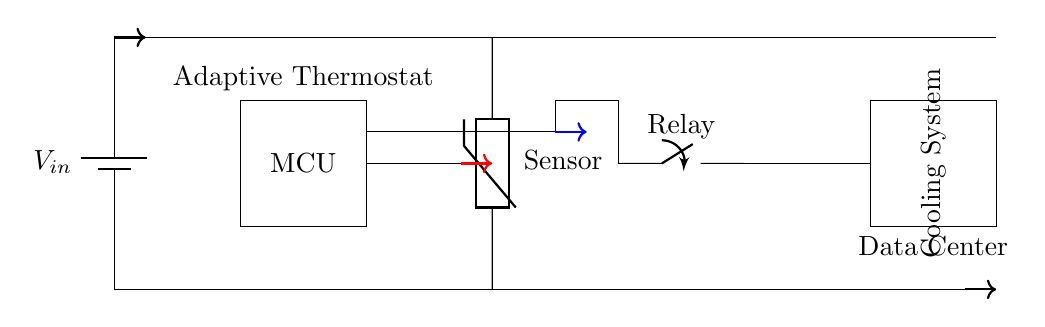What component is used to sense temperature in this circuit? The component used to sense temperature is labeled as "Sensor" in the circuit, which represents a thermistor.
Answer: Thermistor What is the role of the relay in this circuit? The relay in the circuit is labeled as "Relay" and is used to control the power to the cooling system, allowing it to turn on or off based on the commands from the microcontroller.
Answer: Control power What does "MCU" stand for? "MCU" stands for Microcontroller Unit, which is responsible for processing the temperature data and deciding when to activate the relay for the cooling system.
Answer: Microcontroller Unit What is the purpose of the cooling system in the data center? The cooling system's purpose is to maintain optimal temperature conditions within the data center to prevent overheating of the equipment, thus ensuring efficient operation.
Answer: Maintain optimal temperature How does the adaptive thermostat communicate with the temperature sensor? The adaptive thermostat (represented by the microcontroller) receives temperature data from the sensor through a direct connection represented in blue in the diagram; this allows the MCU to make decisions based on the current temperature readings.
Answer: Direct connection What type of circuit is represented in this diagram? The circuit represents a control circuit designed for adaptive thermostat functionality specifically tailored for managing the cooling of high power appliances in a data center.
Answer: Control circuit 